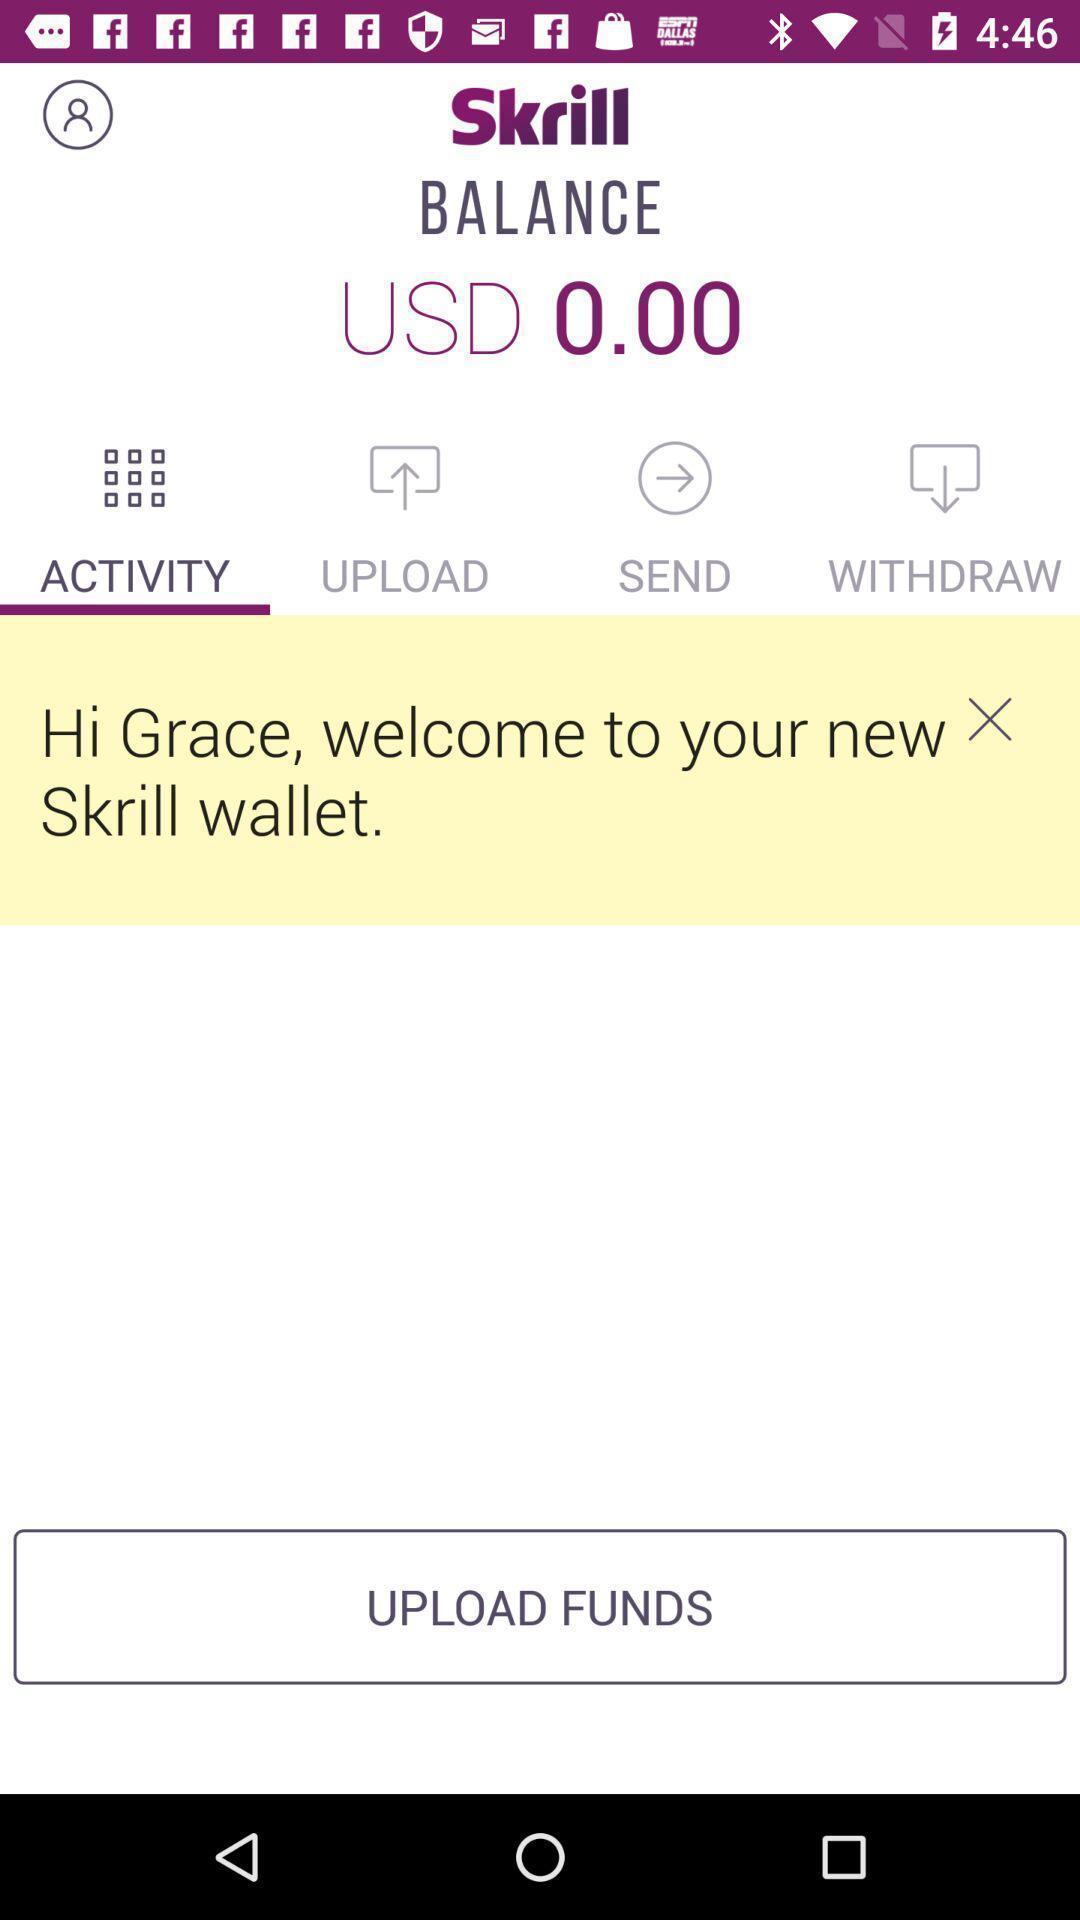Tell me what you see in this picture. Welcome page of a money transaction app. 